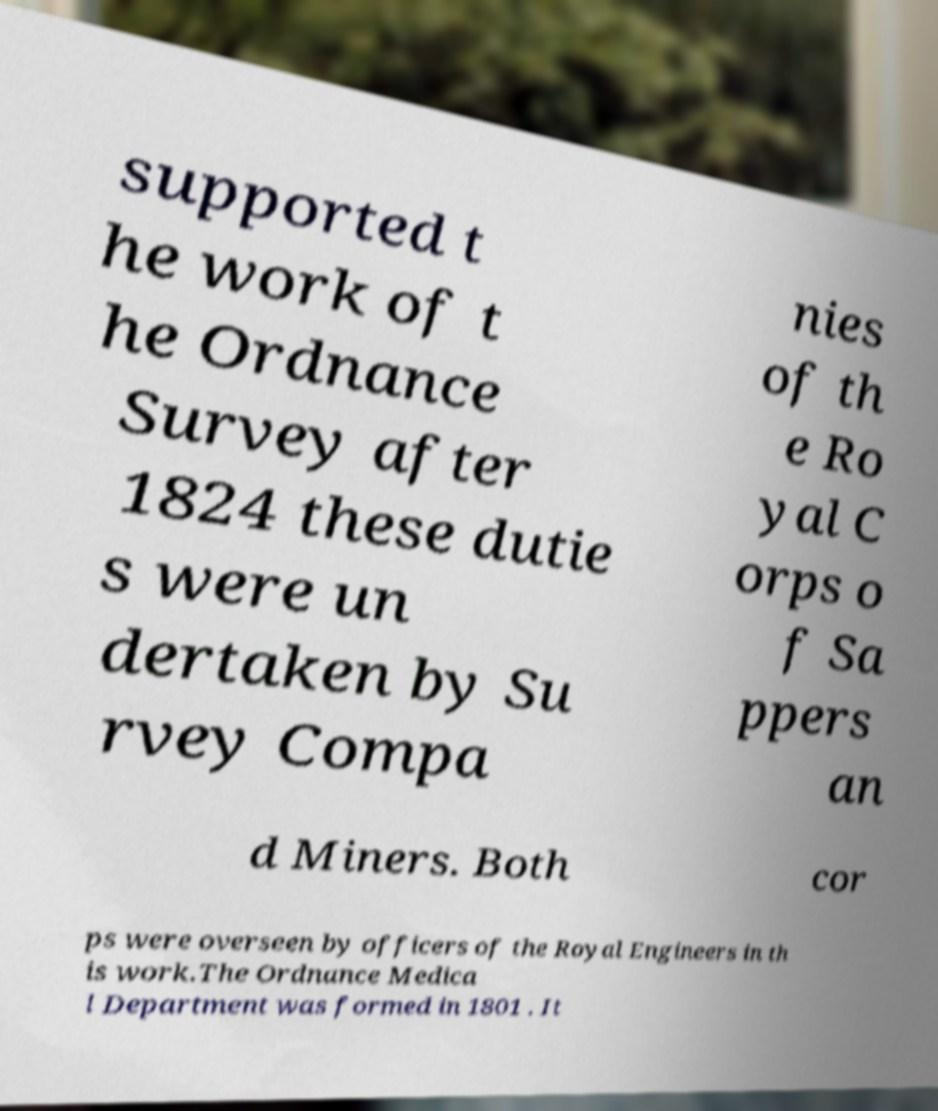Could you assist in decoding the text presented in this image and type it out clearly? supported t he work of t he Ordnance Survey after 1824 these dutie s were un dertaken by Su rvey Compa nies of th e Ro yal C orps o f Sa ppers an d Miners. Both cor ps were overseen by officers of the Royal Engineers in th is work.The Ordnance Medica l Department was formed in 1801 . It 